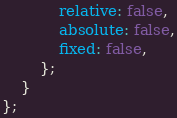<code> <loc_0><loc_0><loc_500><loc_500><_JavaScript_>            relative: false,
            absolute: false,
            fixed: false,
        };
    }
};
</code> 